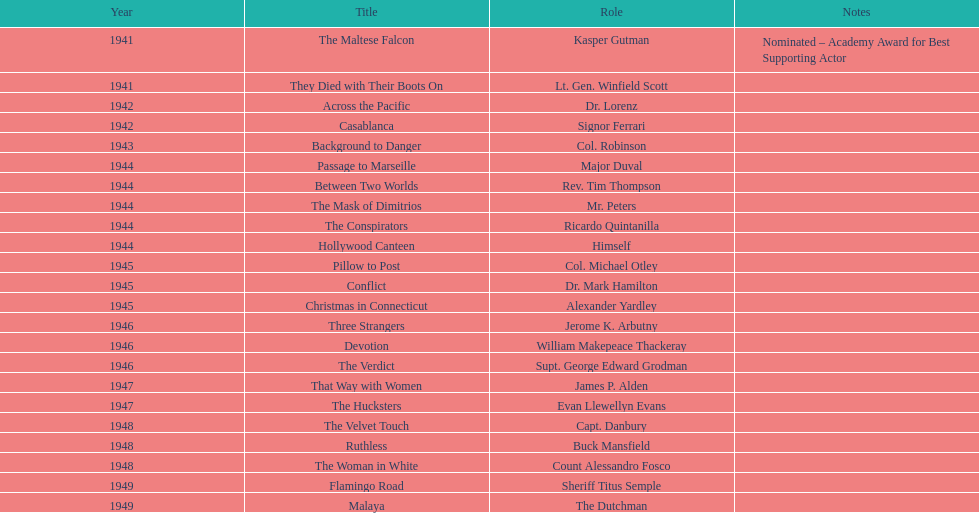Could you parse the entire table as a dict? {'header': ['Year', 'Title', 'Role', 'Notes'], 'rows': [['1941', 'The Maltese Falcon', 'Kasper Gutman', 'Nominated – Academy Award for Best Supporting Actor'], ['1941', 'They Died with Their Boots On', 'Lt. Gen. Winfield Scott', ''], ['1942', 'Across the Pacific', 'Dr. Lorenz', ''], ['1942', 'Casablanca', 'Signor Ferrari', ''], ['1943', 'Background to Danger', 'Col. Robinson', ''], ['1944', 'Passage to Marseille', 'Major Duval', ''], ['1944', 'Between Two Worlds', 'Rev. Tim Thompson', ''], ['1944', 'The Mask of Dimitrios', 'Mr. Peters', ''], ['1944', 'The Conspirators', 'Ricardo Quintanilla', ''], ['1944', 'Hollywood Canteen', 'Himself', ''], ['1945', 'Pillow to Post', 'Col. Michael Otley', ''], ['1945', 'Conflict', 'Dr. Mark Hamilton', ''], ['1945', 'Christmas in Connecticut', 'Alexander Yardley', ''], ['1946', 'Three Strangers', 'Jerome K. Arbutny', ''], ['1946', 'Devotion', 'William Makepeace Thackeray', ''], ['1946', 'The Verdict', 'Supt. George Edward Grodman', ''], ['1947', 'That Way with Women', 'James P. Alden', ''], ['1947', 'The Hucksters', 'Evan Llewellyn Evans', ''], ['1948', 'The Velvet Touch', 'Capt. Danbury', ''], ['1948', 'Ruthless', 'Buck Mansfield', ''], ['1948', 'The Woman in White', 'Count Alessandro Fosco', ''], ['1949', 'Flamingo Road', 'Sheriff Titus Semple', ''], ['1949', 'Malaya', 'The Dutchman', '']]} Which year was the motion picture that was nominated? 1941. What was the motion picture's name? The Maltese Falcon. 